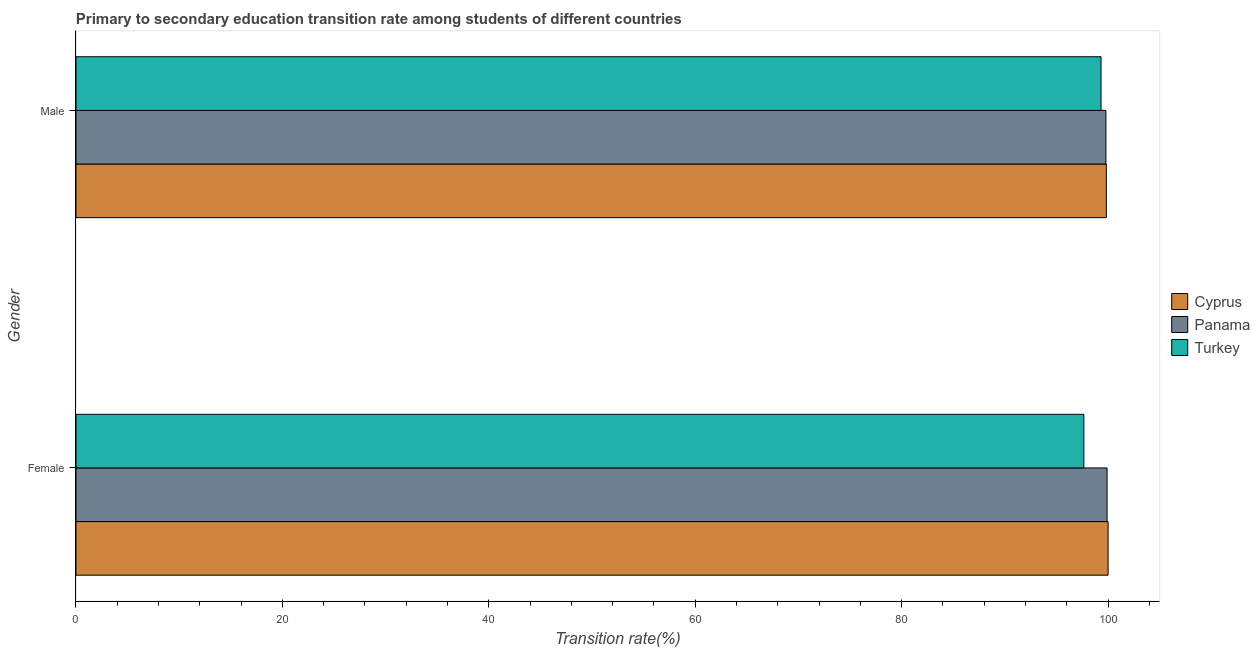How many different coloured bars are there?
Offer a very short reply. 3. Are the number of bars on each tick of the Y-axis equal?
Your response must be concise. Yes. How many bars are there on the 1st tick from the bottom?
Provide a succinct answer. 3. Across all countries, what is the maximum transition rate among male students?
Ensure brevity in your answer.  99.83. Across all countries, what is the minimum transition rate among female students?
Provide a succinct answer. 97.65. In which country was the transition rate among male students maximum?
Provide a short and direct response. Cyprus. In which country was the transition rate among female students minimum?
Your answer should be compact. Turkey. What is the total transition rate among female students in the graph?
Offer a terse response. 297.55. What is the difference between the transition rate among male students in Cyprus and that in Panama?
Give a very brief answer. 0.05. What is the difference between the transition rate among female students in Turkey and the transition rate among male students in Cyprus?
Offer a terse response. -2.18. What is the average transition rate among male students per country?
Offer a very short reply. 99.65. What is the difference between the transition rate among male students and transition rate among female students in Cyprus?
Offer a very short reply. -0.17. In how many countries, is the transition rate among male students greater than 4 %?
Your answer should be very brief. 3. What is the ratio of the transition rate among male students in Panama to that in Cyprus?
Make the answer very short. 1. What does the 2nd bar from the bottom in Male represents?
Your answer should be very brief. Panama. How many bars are there?
Ensure brevity in your answer.  6. How many countries are there in the graph?
Your answer should be compact. 3. Are the values on the major ticks of X-axis written in scientific E-notation?
Offer a terse response. No. Does the graph contain grids?
Keep it short and to the point. No. Where does the legend appear in the graph?
Provide a short and direct response. Center right. What is the title of the graph?
Your response must be concise. Primary to secondary education transition rate among students of different countries. What is the label or title of the X-axis?
Your answer should be very brief. Transition rate(%). What is the label or title of the Y-axis?
Your answer should be compact. Gender. What is the Transition rate(%) in Panama in Female?
Provide a succinct answer. 99.9. What is the Transition rate(%) of Turkey in Female?
Your answer should be very brief. 97.65. What is the Transition rate(%) of Cyprus in Male?
Offer a very short reply. 99.83. What is the Transition rate(%) in Panama in Male?
Offer a terse response. 99.79. What is the Transition rate(%) in Turkey in Male?
Your answer should be compact. 99.32. Across all Gender, what is the maximum Transition rate(%) of Cyprus?
Your response must be concise. 100. Across all Gender, what is the maximum Transition rate(%) in Panama?
Ensure brevity in your answer.  99.9. Across all Gender, what is the maximum Transition rate(%) of Turkey?
Your answer should be very brief. 99.32. Across all Gender, what is the minimum Transition rate(%) of Cyprus?
Your answer should be very brief. 99.83. Across all Gender, what is the minimum Transition rate(%) in Panama?
Provide a succinct answer. 99.79. Across all Gender, what is the minimum Transition rate(%) in Turkey?
Offer a terse response. 97.65. What is the total Transition rate(%) in Cyprus in the graph?
Offer a very short reply. 199.83. What is the total Transition rate(%) of Panama in the graph?
Offer a terse response. 199.69. What is the total Transition rate(%) of Turkey in the graph?
Provide a succinct answer. 196.97. What is the difference between the Transition rate(%) of Cyprus in Female and that in Male?
Provide a short and direct response. 0.17. What is the difference between the Transition rate(%) in Panama in Female and that in Male?
Offer a very short reply. 0.11. What is the difference between the Transition rate(%) of Turkey in Female and that in Male?
Give a very brief answer. -1.66. What is the difference between the Transition rate(%) in Cyprus in Female and the Transition rate(%) in Panama in Male?
Offer a very short reply. 0.21. What is the difference between the Transition rate(%) in Cyprus in Female and the Transition rate(%) in Turkey in Male?
Keep it short and to the point. 0.68. What is the difference between the Transition rate(%) of Panama in Female and the Transition rate(%) of Turkey in Male?
Provide a succinct answer. 0.58. What is the average Transition rate(%) in Cyprus per Gender?
Provide a succinct answer. 99.92. What is the average Transition rate(%) of Panama per Gender?
Offer a terse response. 99.84. What is the average Transition rate(%) of Turkey per Gender?
Make the answer very short. 98.48. What is the difference between the Transition rate(%) in Cyprus and Transition rate(%) in Panama in Female?
Your response must be concise. 0.1. What is the difference between the Transition rate(%) of Cyprus and Transition rate(%) of Turkey in Female?
Keep it short and to the point. 2.35. What is the difference between the Transition rate(%) in Panama and Transition rate(%) in Turkey in Female?
Your response must be concise. 2.25. What is the difference between the Transition rate(%) of Cyprus and Transition rate(%) of Panama in Male?
Make the answer very short. 0.05. What is the difference between the Transition rate(%) in Cyprus and Transition rate(%) in Turkey in Male?
Your answer should be compact. 0.52. What is the difference between the Transition rate(%) in Panama and Transition rate(%) in Turkey in Male?
Offer a very short reply. 0.47. What is the ratio of the Transition rate(%) in Cyprus in Female to that in Male?
Give a very brief answer. 1. What is the ratio of the Transition rate(%) of Turkey in Female to that in Male?
Offer a terse response. 0.98. What is the difference between the highest and the second highest Transition rate(%) of Cyprus?
Make the answer very short. 0.17. What is the difference between the highest and the second highest Transition rate(%) in Panama?
Provide a short and direct response. 0.11. What is the difference between the highest and the second highest Transition rate(%) of Turkey?
Offer a very short reply. 1.66. What is the difference between the highest and the lowest Transition rate(%) in Cyprus?
Your response must be concise. 0.17. What is the difference between the highest and the lowest Transition rate(%) in Panama?
Give a very brief answer. 0.11. What is the difference between the highest and the lowest Transition rate(%) in Turkey?
Your answer should be compact. 1.66. 